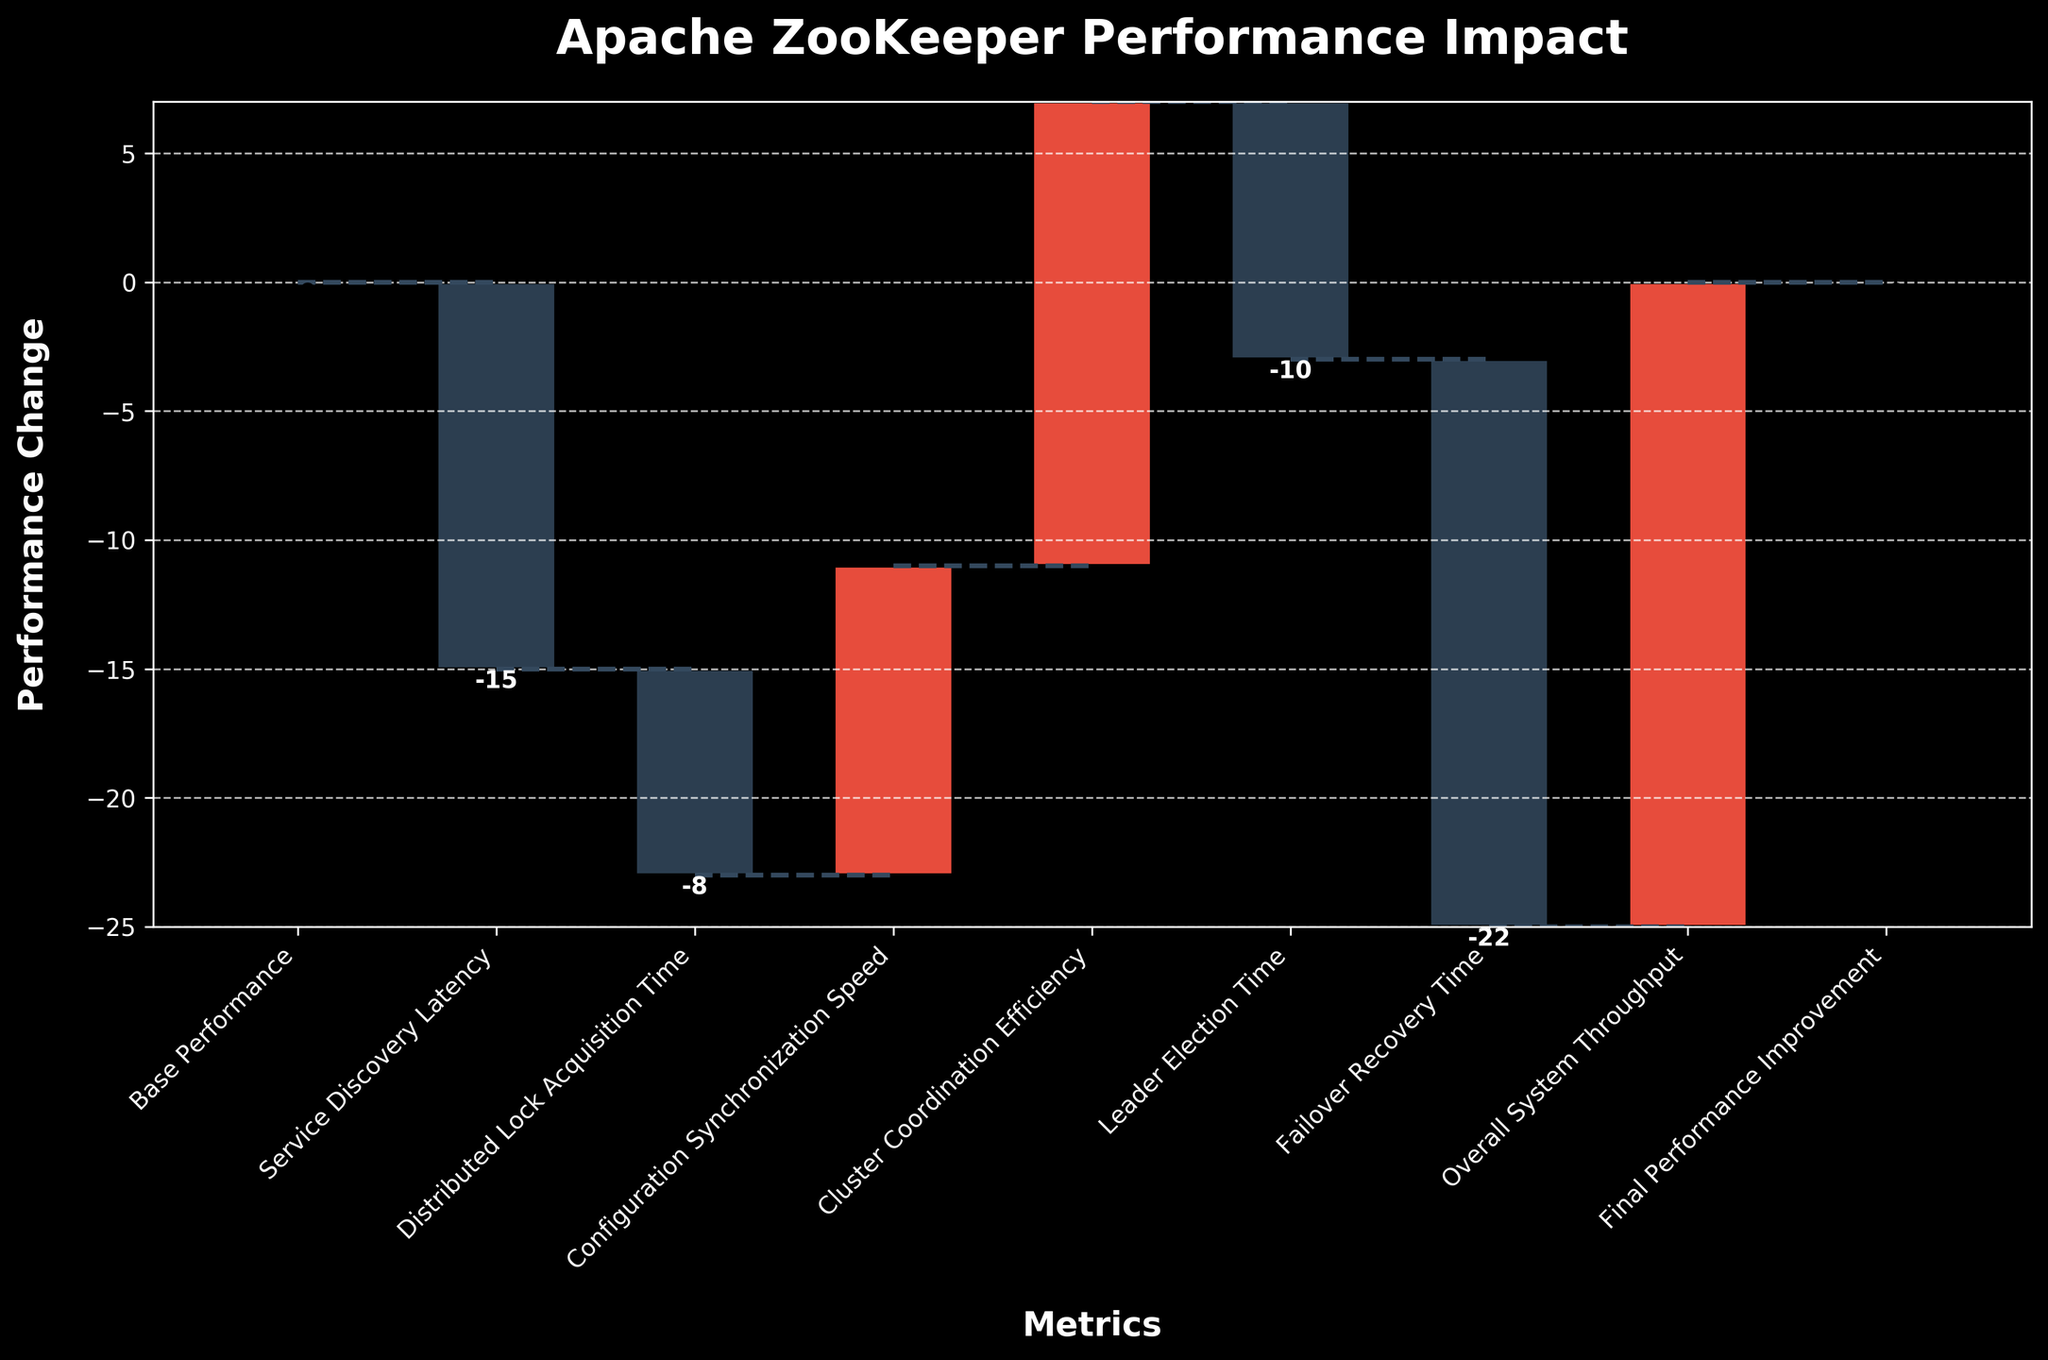What is the title of the plot? The title of the plot is located at the top and it provides an overall summary of what the plot represents. The title here is "Apache ZooKeeper Performance Impact."
Answer: Apache ZooKeeper Performance Impact What is the performance change for 'Distributed Lock Acquisition Time'? Look at the bar labeled 'Distributed Lock Acquisition Time.' The value next to it is the performance change. Here it is -8.
Answer: -8 Which metric shows the highest negative impact on performance? Among the negative values on the y-axis, 'Failover Recovery Time' shows the lowest value, indicating the highest negative impact.
Answer: Failover Recovery Time How many metrics show a positive impact on performance? By counting the bars colored in a different color to indicate positive impact, we can determine that there are three positive impacts: 'Configuration Synchronization Speed,' 'Cluster Coordination Efficiency,' and 'Overall System Throughput.'
Answer: 3 What is the cumulative performance improvement after 'Cluster Coordination Efficiency'? By adding the incremental changes up to 'Cluster Coordination Efficiency,' the cumulative performance improvement can be determined: 0 + (-15) + (-8) + 12 + 18 = 7.
Answer: 7 What is the overall system throughput improvement? Look at the bar labeled 'Overall System Throughput.' The corresponding value is the performance improvement, which is 25.
Answer: 25 Which metric comes immediately after 'Leader Election Time'? The metric immediately following 'Leader Election Time' can be identified by reading the labels in sequence. It is 'Failover Recovery Time.'
Answer: Failover Recovery Time How does the impact of 'Service Discovery Latency' compare to 'Leader Election Time'? We need to compare the values for 'Service Discovery Latency' (-15) and 'Leader Election Time' (-10). 'Service Discovery Latency' has a more negative impact.
Answer: Service Discovery Latency has a more negative impact What is the cumulative performance change at the end of all metrics? The final cumulative value considering all incremental changes, ending with 'Final Performance Improvement,' is 0.
Answer: 0 What is the sum of all positive impacts? The positive changes are: 12 (Configuration Synchronization Speed) + 18 (Cluster Coordination Efficiency) + 25 (Overall System Throughput). Summing these values gives 12 + 18 + 25 = 55.
Answer: 55 